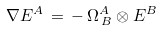<formula> <loc_0><loc_0><loc_500><loc_500>\nabla E ^ { A } \, = \, - \, \Omega _ { \, B } ^ { A } \otimes E ^ { B }</formula> 